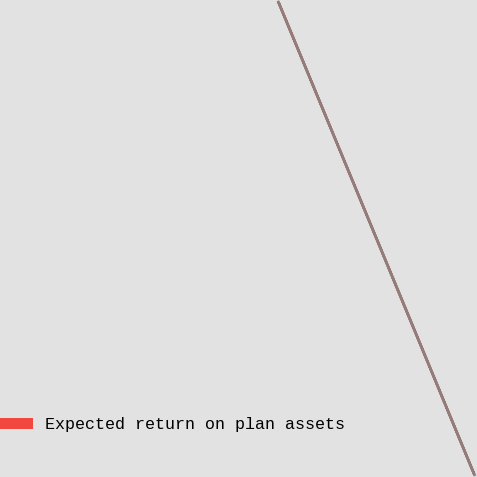<chart> <loc_0><loc_0><loc_500><loc_500><pie_chart><fcel>Expected return on plan assets<nl><fcel>100.0%<nl></chart> 